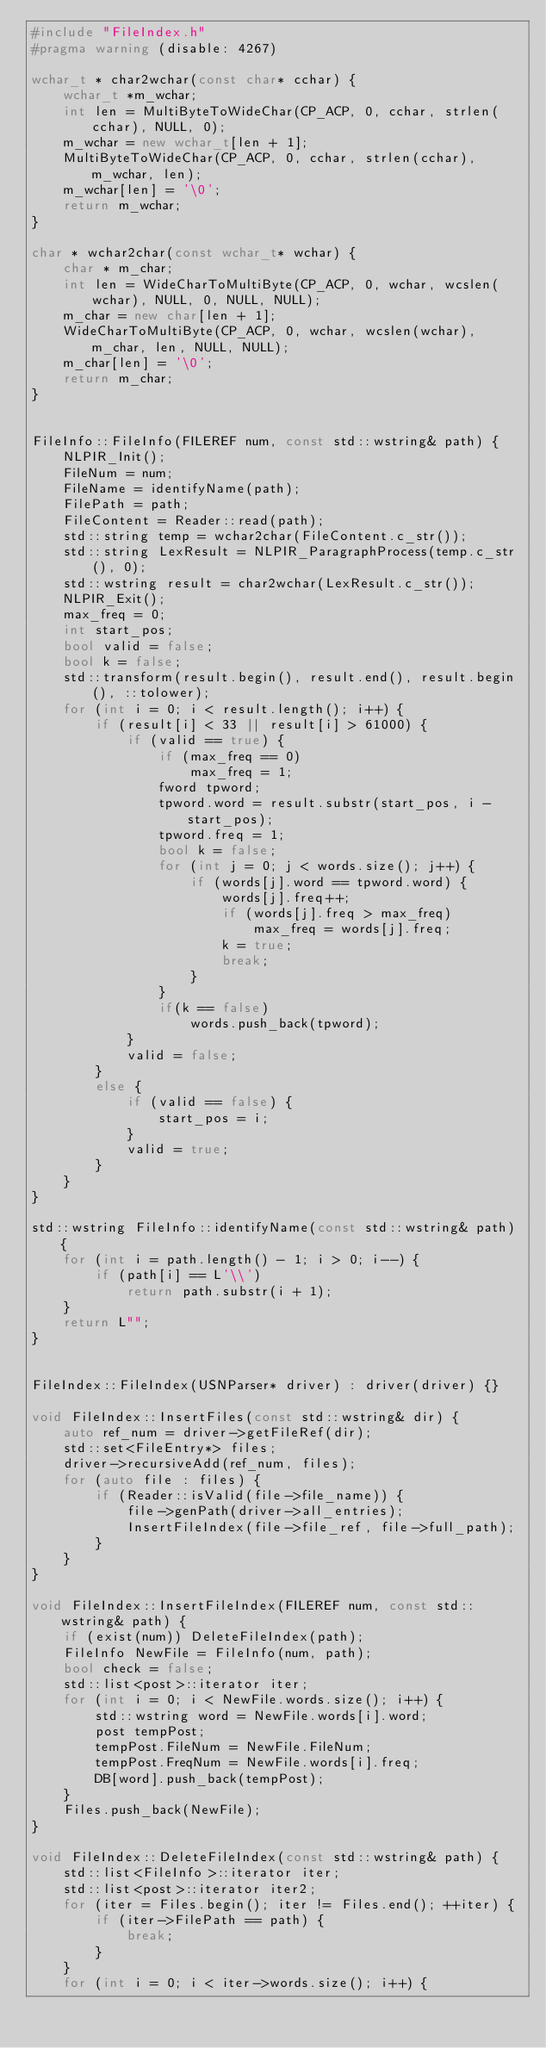Convert code to text. <code><loc_0><loc_0><loc_500><loc_500><_C++_>#include "FileIndex.h"
#pragma warning (disable: 4267)

wchar_t * char2wchar(const char* cchar) {
	wchar_t *m_wchar;
	int len = MultiByteToWideChar(CP_ACP, 0, cchar, strlen(cchar), NULL, 0);
	m_wchar = new wchar_t[len + 1];
	MultiByteToWideChar(CP_ACP, 0, cchar, strlen(cchar), m_wchar, len);
	m_wchar[len] = '\0';
	return m_wchar;
}

char * wchar2char(const wchar_t* wchar) {
	char * m_char;
	int len = WideCharToMultiByte(CP_ACP, 0, wchar, wcslen(wchar), NULL, 0, NULL, NULL);
	m_char = new char[len + 1];
	WideCharToMultiByte(CP_ACP, 0, wchar, wcslen(wchar), m_char, len, NULL, NULL);
	m_char[len] = '\0';
	return m_char;
}


FileInfo::FileInfo(FILEREF num, const std::wstring& path) {
	NLPIR_Init();
	FileNum = num;
	FileName = identifyName(path);
	FilePath = path;
	FileContent = Reader::read(path);
	std::string temp = wchar2char(FileContent.c_str());
	std::string LexResult = NLPIR_ParagraphProcess(temp.c_str(), 0);
	std::wstring result = char2wchar(LexResult.c_str());
	NLPIR_Exit();
	max_freq = 0;
	int start_pos;
	bool valid = false;
	bool k = false;
	std::transform(result.begin(), result.end(), result.begin(), ::tolower);
	for (int i = 0; i < result.length(); i++) {
		if (result[i] < 33 || result[i] > 61000) {
			if (valid == true) {
				if (max_freq == 0)
					max_freq = 1;
				fword tpword;
				tpword.word = result.substr(start_pos, i - start_pos);
				tpword.freq = 1;
				bool k = false;
				for (int j = 0; j < words.size(); j++) {
					if (words[j].word == tpword.word) {
						words[j].freq++;
						if (words[j].freq > max_freq)
							max_freq = words[j].freq;
						k = true;
						break;
					}
				}
				if(k == false)
					words.push_back(tpword);
			}
			valid = false;
		}
		else {
			if (valid == false) {
				start_pos = i;
			}
			valid = true;
		}
	}
}

std::wstring FileInfo::identifyName(const std::wstring& path) {
	for (int i = path.length() - 1; i > 0; i--) {
		if (path[i] == L'\\')
			return path.substr(i + 1);
	}
	return L"";
}


FileIndex::FileIndex(USNParser* driver) : driver(driver) {}

void FileIndex::InsertFiles(const std::wstring& dir) {
	auto ref_num = driver->getFileRef(dir);
	std::set<FileEntry*> files;
	driver->recursiveAdd(ref_num, files);
	for (auto file : files) {
		if (Reader::isValid(file->file_name)) {
			file->genPath(driver->all_entries);
			InsertFileIndex(file->file_ref, file->full_path);
		}
	}
}

void FileIndex::InsertFileIndex(FILEREF num, const std::wstring& path) {
	if (exist(num)) DeleteFileIndex(path);
	FileInfo NewFile = FileInfo(num, path);
	bool check = false;
	std::list<post>::iterator iter;
	for (int i = 0; i < NewFile.words.size(); i++) {
		std::wstring word = NewFile.words[i].word;
		post tempPost;
		tempPost.FileNum = NewFile.FileNum;
		tempPost.FreqNum = NewFile.words[i].freq;
		DB[word].push_back(tempPost);
	}
	Files.push_back(NewFile);
}

void FileIndex::DeleteFileIndex(const std::wstring& path) {
	std::list<FileInfo>::iterator iter;
	std::list<post>::iterator iter2;
	for (iter = Files.begin(); iter != Files.end(); ++iter) {
		if (iter->FilePath == path) {
			break;
		}
	}
	for (int i = 0; i < iter->words.size(); i++) {</code> 